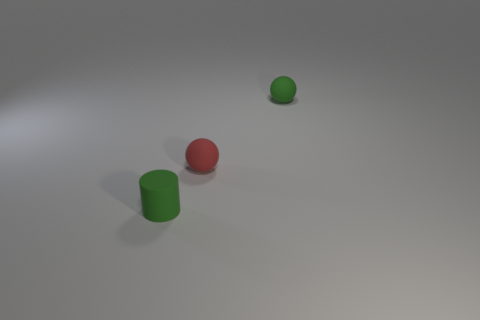There is a sphere that is the same color as the tiny matte cylinder; what is it made of?
Provide a succinct answer. Rubber. Is the color of the rubber cylinder the same as the rubber thing to the right of the small red rubber ball?
Your response must be concise. Yes. Are there more red matte balls than cyan rubber balls?
Ensure brevity in your answer.  Yes. There is a green matte thing that is the same shape as the small red thing; what is its size?
Your response must be concise. Small. Do the red thing and the small green object that is in front of the tiny red object have the same material?
Give a very brief answer. Yes. What number of objects are either gray rubber cylinders or green objects?
Keep it short and to the point. 2. Do the sphere that is behind the red matte sphere and the red rubber thing that is behind the green cylinder have the same size?
Keep it short and to the point. Yes. How many cylinders are green objects or tiny red objects?
Offer a very short reply. 1. Are there any tiny green rubber cylinders?
Provide a short and direct response. Yes. Are there any other things that are the same shape as the small red object?
Provide a short and direct response. Yes. 